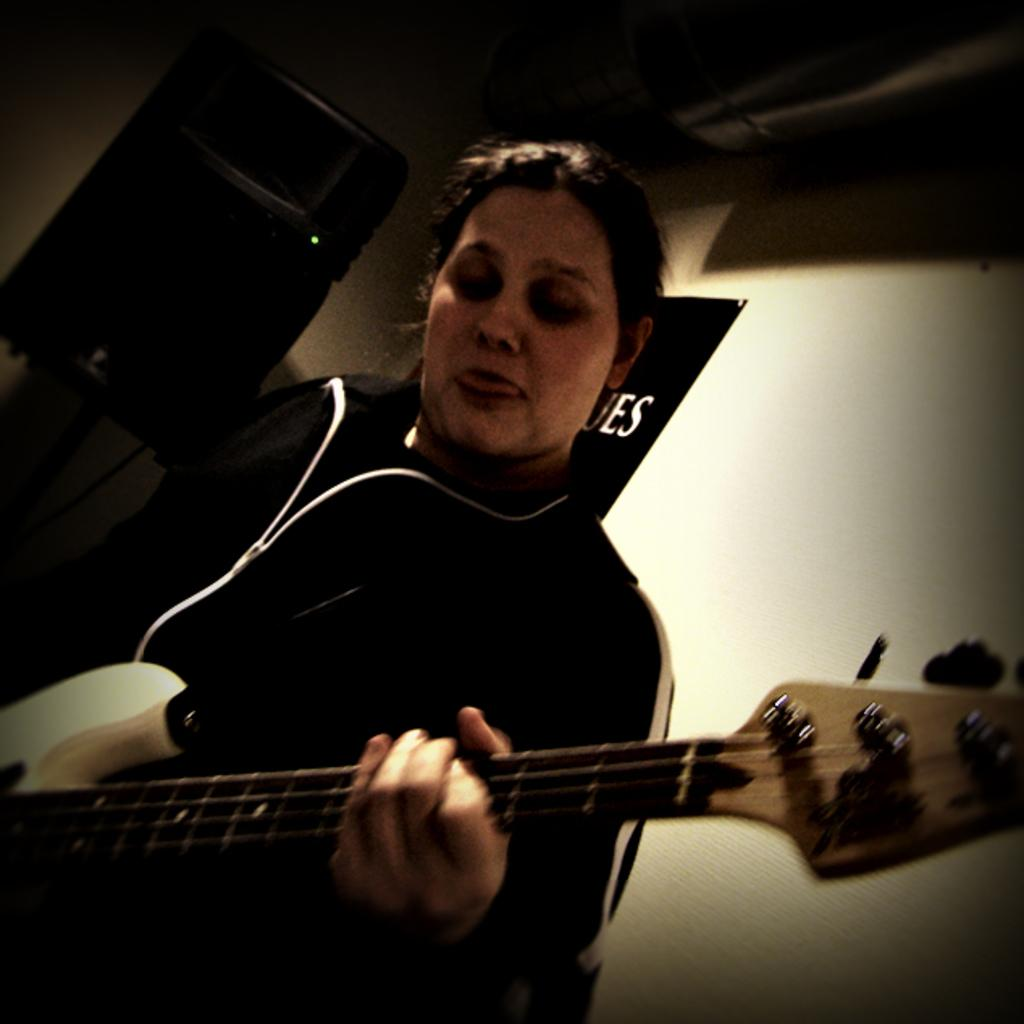Who is the main subject in the image? There is a woman in the image. What is the woman doing in the image? The woman is playing a guitar. What color is the background of the image? The background of the image is white. Can you hear the birds singing in the background of the image? There are no birds or sounds present in the image, as it is a still photograph. 